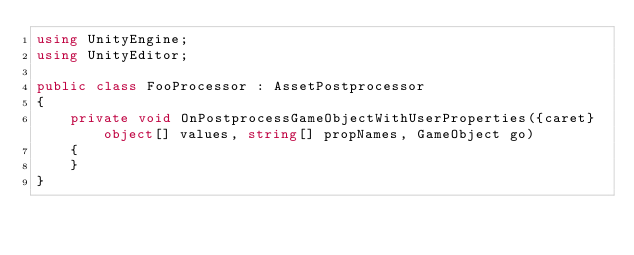Convert code to text. <code><loc_0><loc_0><loc_500><loc_500><_C#_>using UnityEngine;
using UnityEditor;

public class FooProcessor : AssetPostprocessor
{
    private void OnPostprocessGameObjectWithUserProperties({caret}object[] values, string[] propNames, GameObject go)
    {
    }
}</code> 